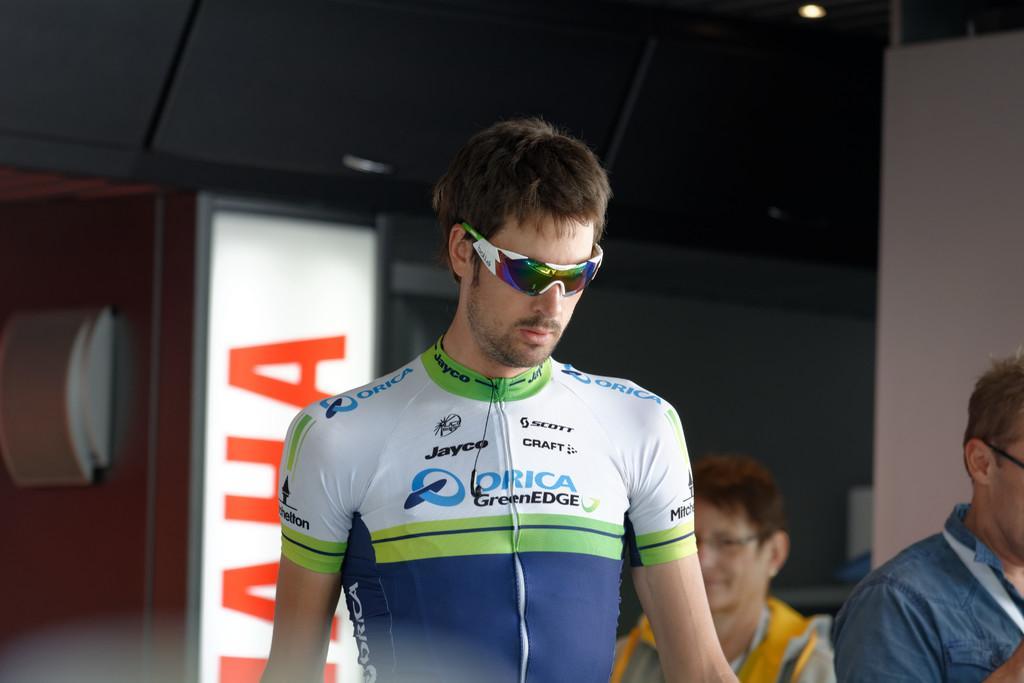Could you give a brief overview of what you see in this image? In this image there is a person with spectacles is standing, and in the background there are two persons, lights, light board. 